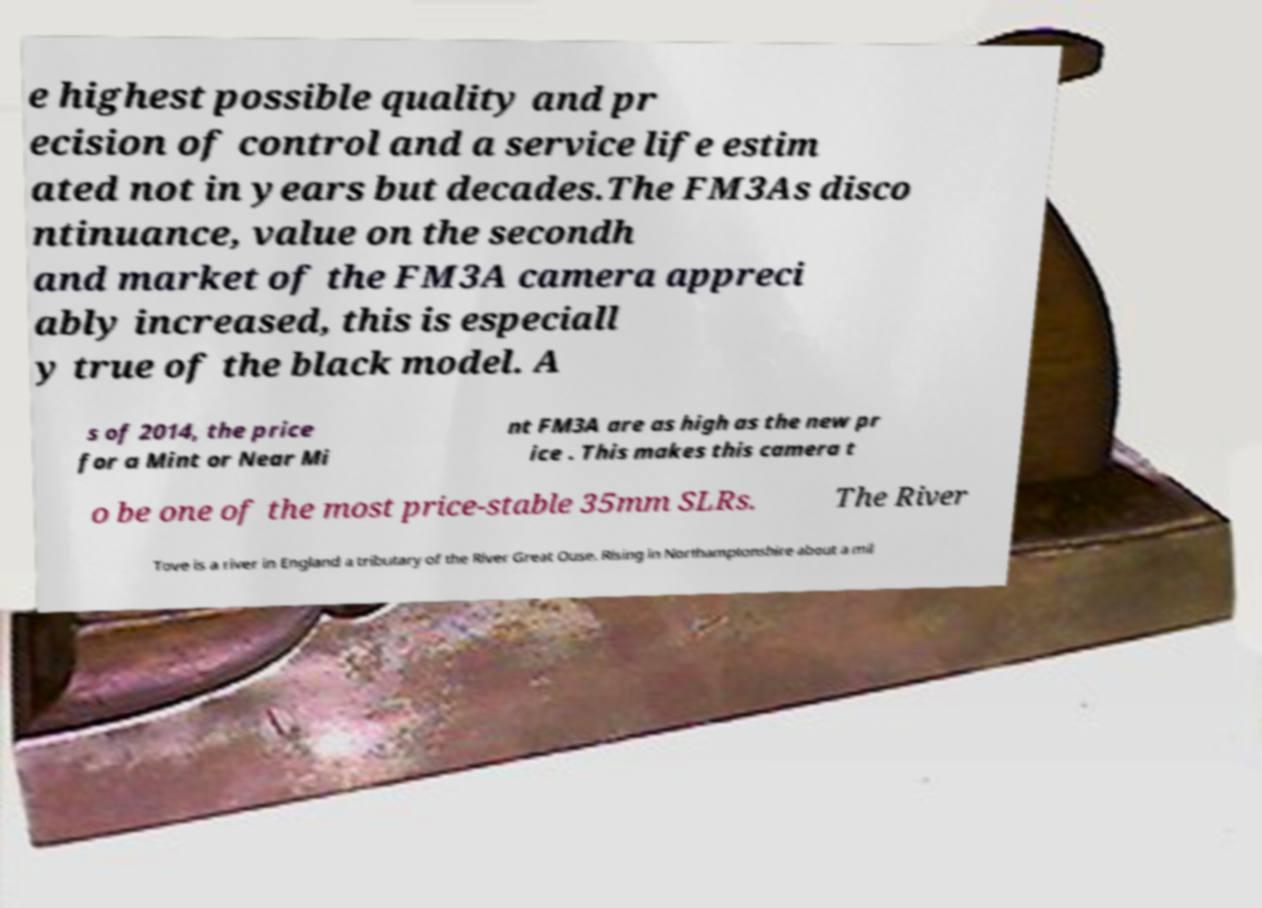I need the written content from this picture converted into text. Can you do that? e highest possible quality and pr ecision of control and a service life estim ated not in years but decades.The FM3As disco ntinuance, value on the secondh and market of the FM3A camera appreci ably increased, this is especiall y true of the black model. A s of 2014, the price for a Mint or Near Mi nt FM3A are as high as the new pr ice . This makes this camera t o be one of the most price-stable 35mm SLRs. The River Tove is a river in England a tributary of the River Great Ouse. Rising in Northamptonshire about a mil 